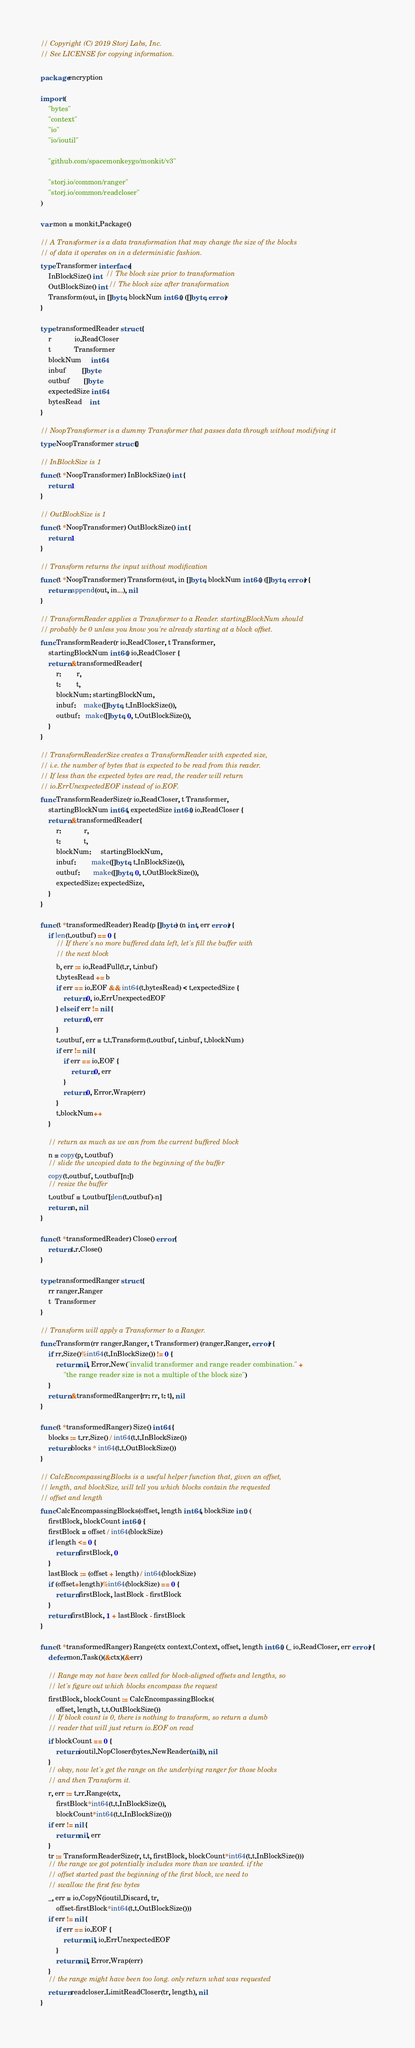<code> <loc_0><loc_0><loc_500><loc_500><_Go_>// Copyright (C) 2019 Storj Labs, Inc.
// See LICENSE for copying information.

package encryption

import (
	"bytes"
	"context"
	"io"
	"io/ioutil"

	"github.com/spacemonkeygo/monkit/v3"

	"storj.io/common/ranger"
	"storj.io/common/readcloser"
)

var mon = monkit.Package()

// A Transformer is a data transformation that may change the size of the blocks
// of data it operates on in a deterministic fashion.
type Transformer interface {
	InBlockSize() int  // The block size prior to transformation
	OutBlockSize() int // The block size after transformation
	Transform(out, in []byte, blockNum int64) ([]byte, error)
}

type transformedReader struct {
	r            io.ReadCloser
	t            Transformer
	blockNum     int64
	inbuf        []byte
	outbuf       []byte
	expectedSize int64
	bytesRead    int
}

// NoopTransformer is a dummy Transformer that passes data through without modifying it
type NoopTransformer struct{}

// InBlockSize is 1
func (t *NoopTransformer) InBlockSize() int {
	return 1
}

// OutBlockSize is 1
func (t *NoopTransformer) OutBlockSize() int {
	return 1
}

// Transform returns the input without modification
func (t *NoopTransformer) Transform(out, in []byte, blockNum int64) ([]byte, error) {
	return append(out, in...), nil
}

// TransformReader applies a Transformer to a Reader. startingBlockNum should
// probably be 0 unless you know you're already starting at a block offset.
func TransformReader(r io.ReadCloser, t Transformer,
	startingBlockNum int64) io.ReadCloser {
	return &transformedReader{
		r:        r,
		t:        t,
		blockNum: startingBlockNum,
		inbuf:    make([]byte, t.InBlockSize()),
		outbuf:   make([]byte, 0, t.OutBlockSize()),
	}
}

// TransformReaderSize creates a TransformReader with expected size,
// i.e. the number of bytes that is expected to be read from this reader.
// If less than the expected bytes are read, the reader will return
// io.ErrUnexpectedEOF instead of io.EOF.
func TransformReaderSize(r io.ReadCloser, t Transformer,
	startingBlockNum int64, expectedSize int64) io.ReadCloser {
	return &transformedReader{
		r:            r,
		t:            t,
		blockNum:     startingBlockNum,
		inbuf:        make([]byte, t.InBlockSize()),
		outbuf:       make([]byte, 0, t.OutBlockSize()),
		expectedSize: expectedSize,
	}
}

func (t *transformedReader) Read(p []byte) (n int, err error) {
	if len(t.outbuf) == 0 {
		// If there's no more buffered data left, let's fill the buffer with
		// the next block
		b, err := io.ReadFull(t.r, t.inbuf)
		t.bytesRead += b
		if err == io.EOF && int64(t.bytesRead) < t.expectedSize {
			return 0, io.ErrUnexpectedEOF
		} else if err != nil {
			return 0, err
		}
		t.outbuf, err = t.t.Transform(t.outbuf, t.inbuf, t.blockNum)
		if err != nil {
			if err == io.EOF {
				return 0, err
			}
			return 0, Error.Wrap(err)
		}
		t.blockNum++
	}

	// return as much as we can from the current buffered block
	n = copy(p, t.outbuf)
	// slide the uncopied data to the beginning of the buffer
	copy(t.outbuf, t.outbuf[n:])
	// resize the buffer
	t.outbuf = t.outbuf[:len(t.outbuf)-n]
	return n, nil
}

func (t *transformedReader) Close() error {
	return t.r.Close()
}

type transformedRanger struct {
	rr ranger.Ranger
	t  Transformer
}

// Transform will apply a Transformer to a Ranger.
func Transform(rr ranger.Ranger, t Transformer) (ranger.Ranger, error) {
	if rr.Size()%int64(t.InBlockSize()) != 0 {
		return nil, Error.New("invalid transformer and range reader combination." +
			"the range reader size is not a multiple of the block size")
	}
	return &transformedRanger{rr: rr, t: t}, nil
}

func (t *transformedRanger) Size() int64 {
	blocks := t.rr.Size() / int64(t.t.InBlockSize())
	return blocks * int64(t.t.OutBlockSize())
}

// CalcEncompassingBlocks is a useful helper function that, given an offset,
// length, and blockSize, will tell you which blocks contain the requested
// offset and length
func CalcEncompassingBlocks(offset, length int64, blockSize int) (
	firstBlock, blockCount int64) {
	firstBlock = offset / int64(blockSize)
	if length <= 0 {
		return firstBlock, 0
	}
	lastBlock := (offset + length) / int64(blockSize)
	if (offset+length)%int64(blockSize) == 0 {
		return firstBlock, lastBlock - firstBlock
	}
	return firstBlock, 1 + lastBlock - firstBlock
}

func (t *transformedRanger) Range(ctx context.Context, offset, length int64) (_ io.ReadCloser, err error) {
	defer mon.Task()(&ctx)(&err)

	// Range may not have been called for block-aligned offsets and lengths, so
	// let's figure out which blocks encompass the request
	firstBlock, blockCount := CalcEncompassingBlocks(
		offset, length, t.t.OutBlockSize())
	// If block count is 0, there is nothing to transform, so return a dumb
	// reader that will just return io.EOF on read
	if blockCount == 0 {
		return ioutil.NopCloser(bytes.NewReader(nil)), nil
	}
	// okay, now let's get the range on the underlying ranger for those blocks
	// and then Transform it.
	r, err := t.rr.Range(ctx,
		firstBlock*int64(t.t.InBlockSize()),
		blockCount*int64(t.t.InBlockSize()))
	if err != nil {
		return nil, err
	}
	tr := TransformReaderSize(r, t.t, firstBlock, blockCount*int64(t.t.InBlockSize()))
	// the range we got potentially includes more than we wanted. if the
	// offset started past the beginning of the first block, we need to
	// swallow the first few bytes
	_, err = io.CopyN(ioutil.Discard, tr,
		offset-firstBlock*int64(t.t.OutBlockSize()))
	if err != nil {
		if err == io.EOF {
			return nil, io.ErrUnexpectedEOF
		}
		return nil, Error.Wrap(err)
	}
	// the range might have been too long. only return what was requested
	return readcloser.LimitReadCloser(tr, length), nil
}
</code> 